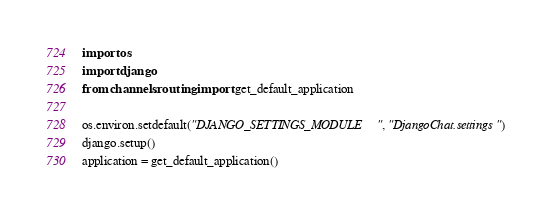<code> <loc_0><loc_0><loc_500><loc_500><_Python_>import os
import django
from channels.routing import get_default_application

os.environ.setdefault("DJANGO_SETTINGS_MODULE", "DjangoChat.settings")
django.setup()
application = get_default_application()</code> 